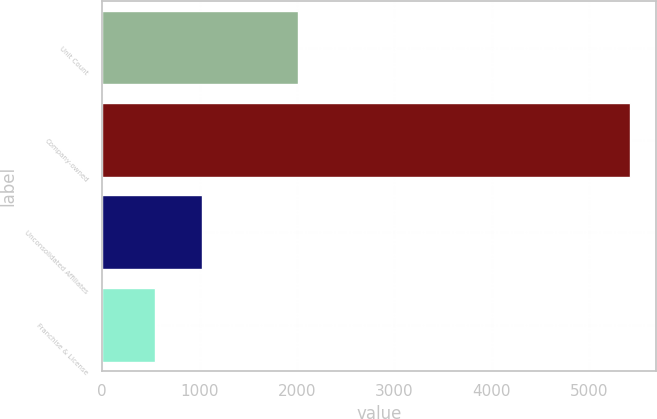<chart> <loc_0><loc_0><loc_500><loc_500><bar_chart><fcel>Unit Count<fcel>Company-owned<fcel>Unconsolidated Affiliates<fcel>Franchise & License<nl><fcel>2014<fcel>5417<fcel>1028.6<fcel>541<nl></chart> 